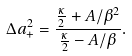Convert formula to latex. <formula><loc_0><loc_0><loc_500><loc_500>\Delta a _ { + } ^ { 2 } = \frac { \frac { \kappa } { 2 } + A / \beta ^ { 2 } } { \frac { \kappa } { 2 } - A / \beta } .</formula> 